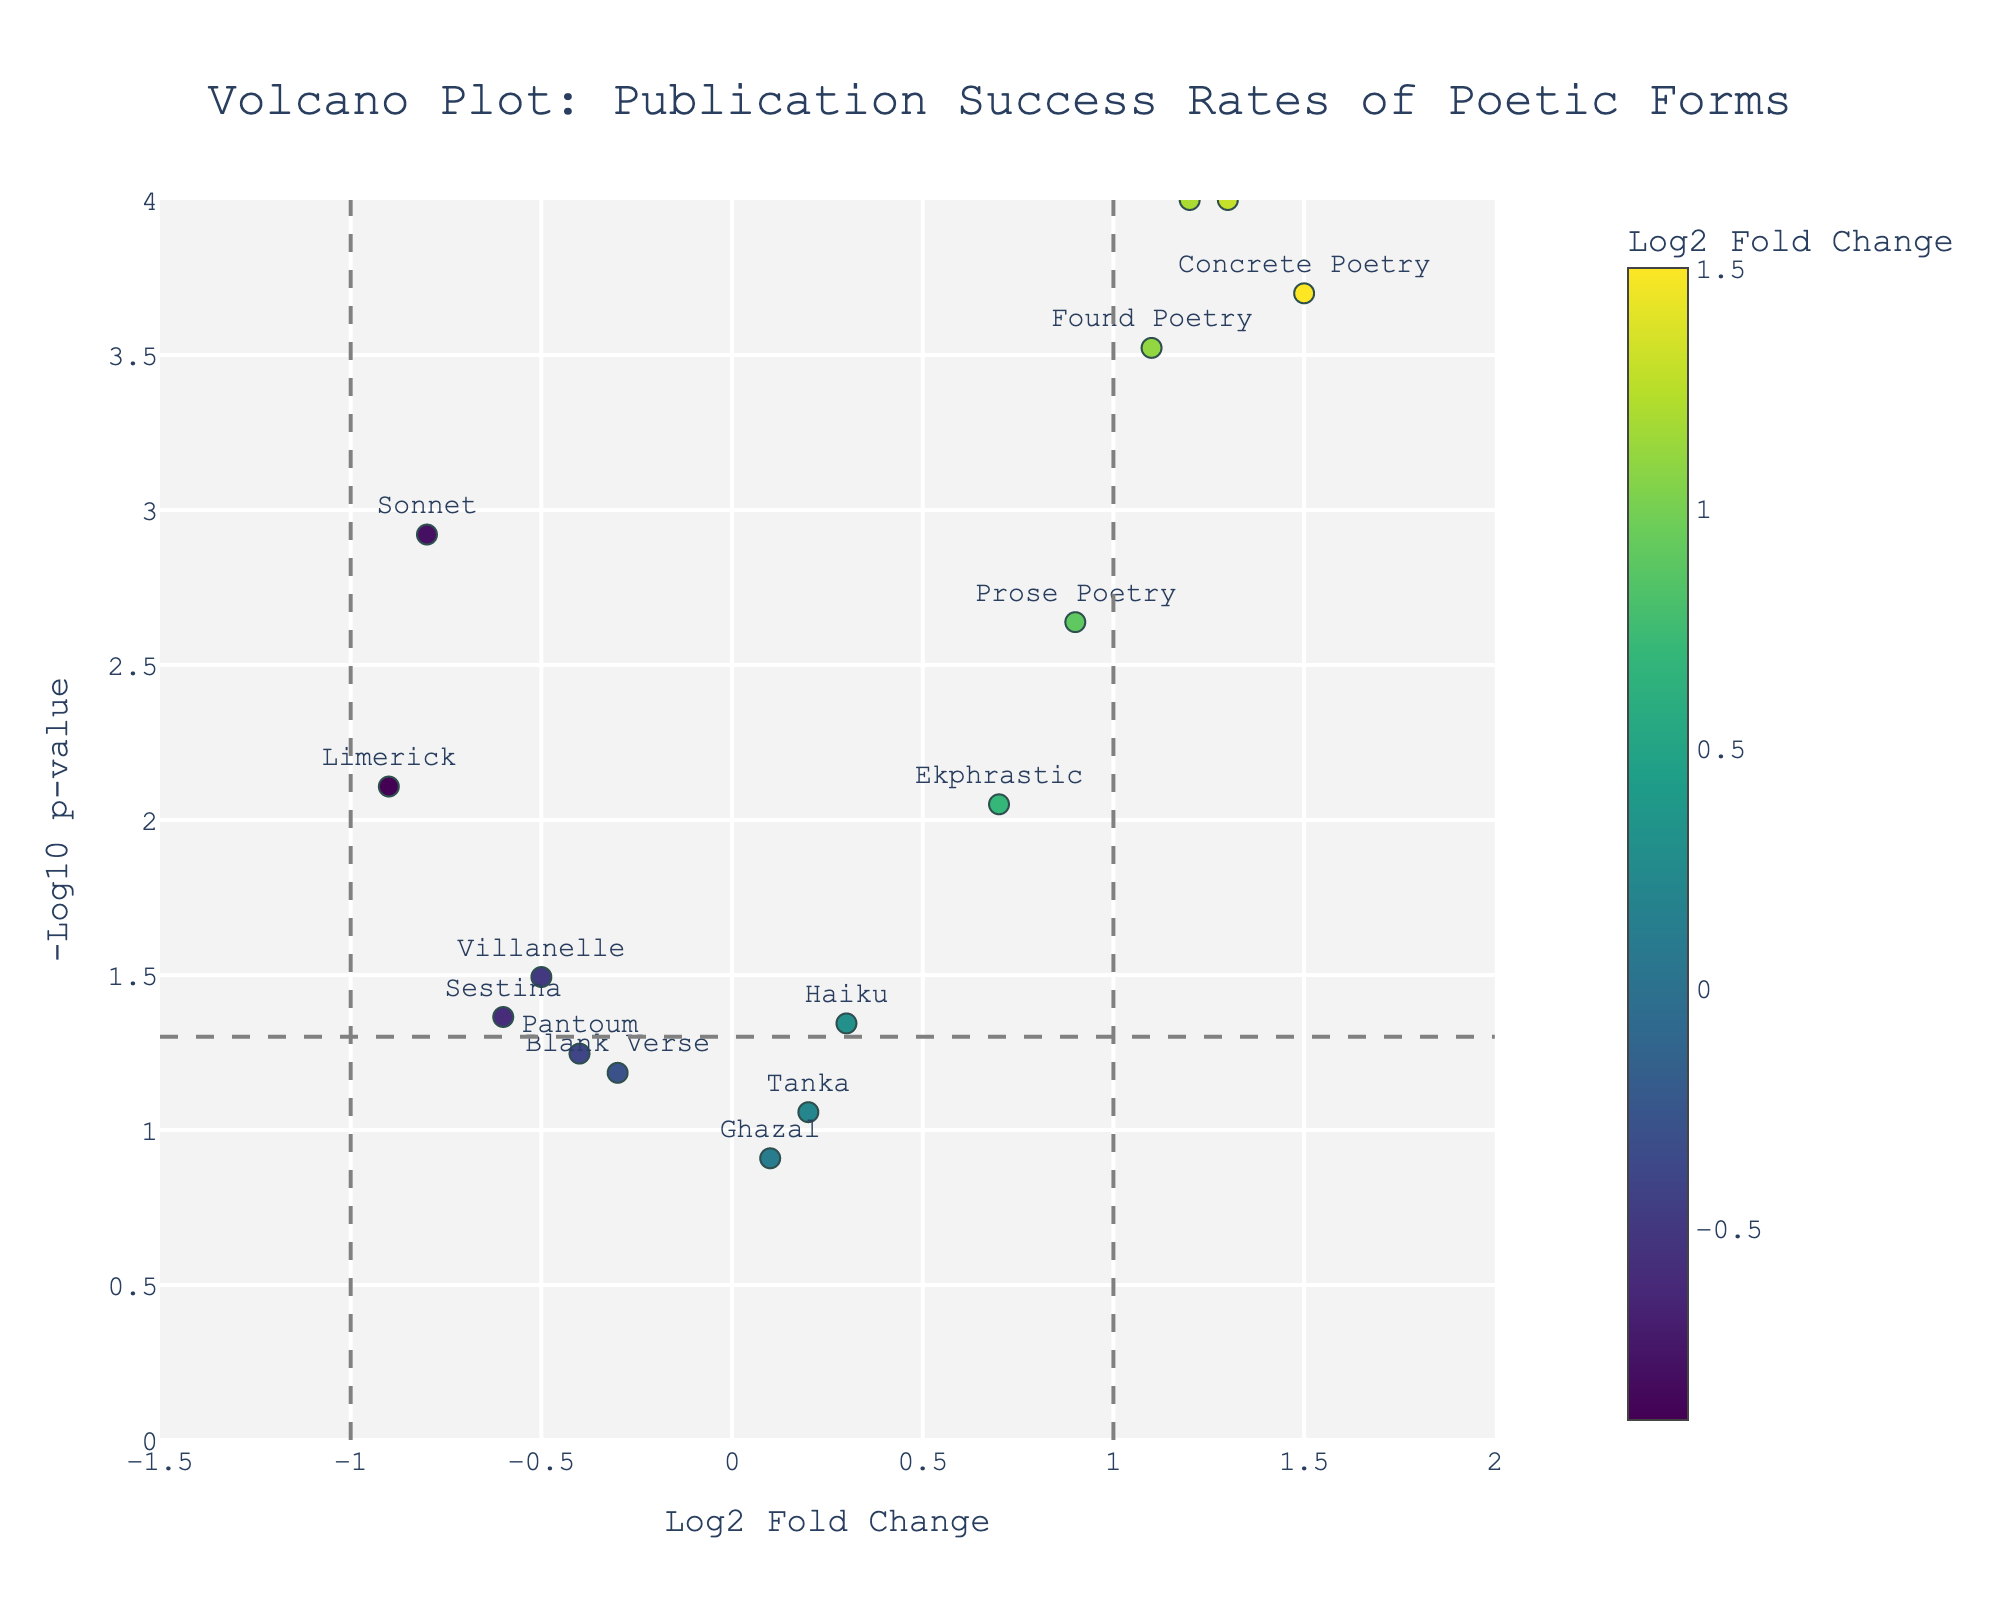What is the title of the figure? The title is typically displayed at the top of the figure and provides a description of the data being visualized. In this case, you should read the title directly from the plot.
Answer: Volcano Plot: Publication Success Rates of Poetic Forms How many data points are above the horizontal line? The horizontal line denotes a significant p-value threshold. Count the number of markers above this line.
Answer: 9 Which poetic form has the highest log2 fold change? Identify the point with the largest x-value (log2 fold change). The hover text should provide the specific name.
Answer: Concrete Poetry Which poetic form is closest to the vertical line at log2 fold change = 0? Identify the point closest to the x-axis at zero, which represents no change in publication success rate. Check the point's hover text for details.
Answer: Ghazal Which poetic form has the lowest -log10(p-value)? Find the point with the smallest y-value (-log10 p-value). The hover text will display the poetic form.
Answer: Ghazal Which poetic forms fall under traditional styles? Sonnet, Villanelle, Limerick, Sestina, and Blank Verse typically represent traditional styles.
Answer: Sonnet, Villanelle, Limerick, Sestina, Blank Verse How many poetic forms have a positive log2 fold change and are statistically significant (p < 0.05)? Identify points with positive x-values and y-values above the horizontal significance line. Count these points.
Answer: 5 What is the average log2 fold change for experimental forms? Calculate the average of the log2 fold changes for forms like Free Verse, Concrete Poetry, Erasure Poetry, and Found Poetry.
Answer: 1.275 Which traditional poetic form has the least significant (highest) p-value? Among traditional forms, identify the one with the smallest -log10(p-value) (i.e., highest p-value).
Answer: Pantoum 